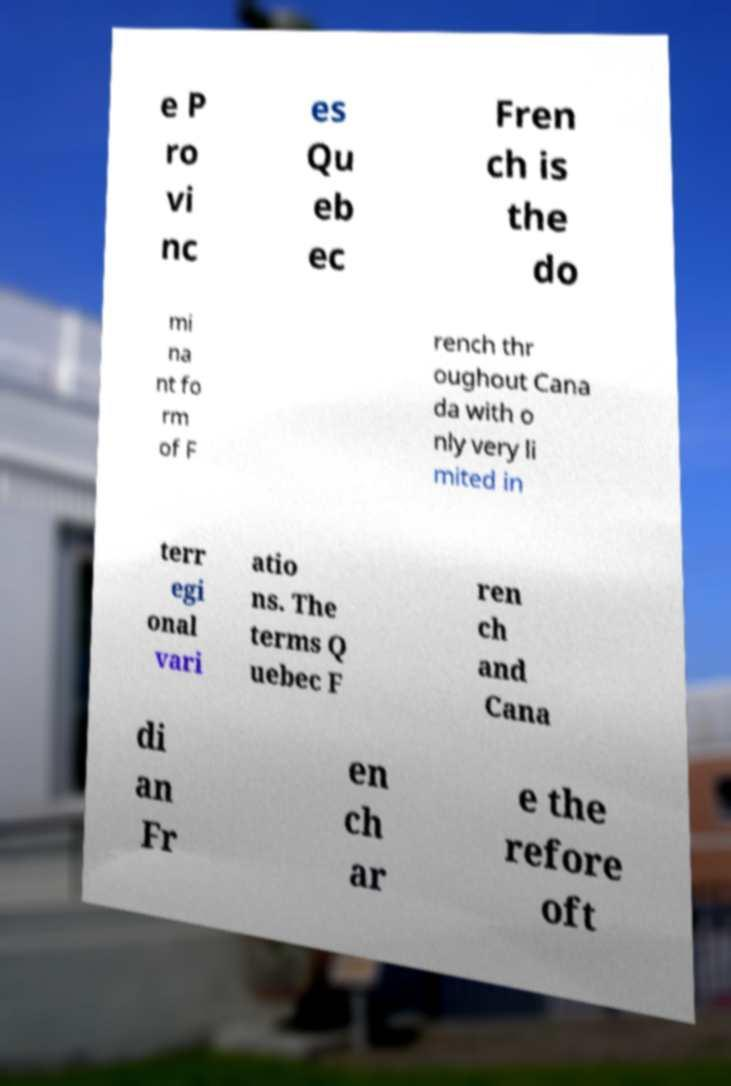There's text embedded in this image that I need extracted. Can you transcribe it verbatim? e P ro vi nc es Qu eb ec Fren ch is the do mi na nt fo rm of F rench thr oughout Cana da with o nly very li mited in terr egi onal vari atio ns. The terms Q uebec F ren ch and Cana di an Fr en ch ar e the refore oft 